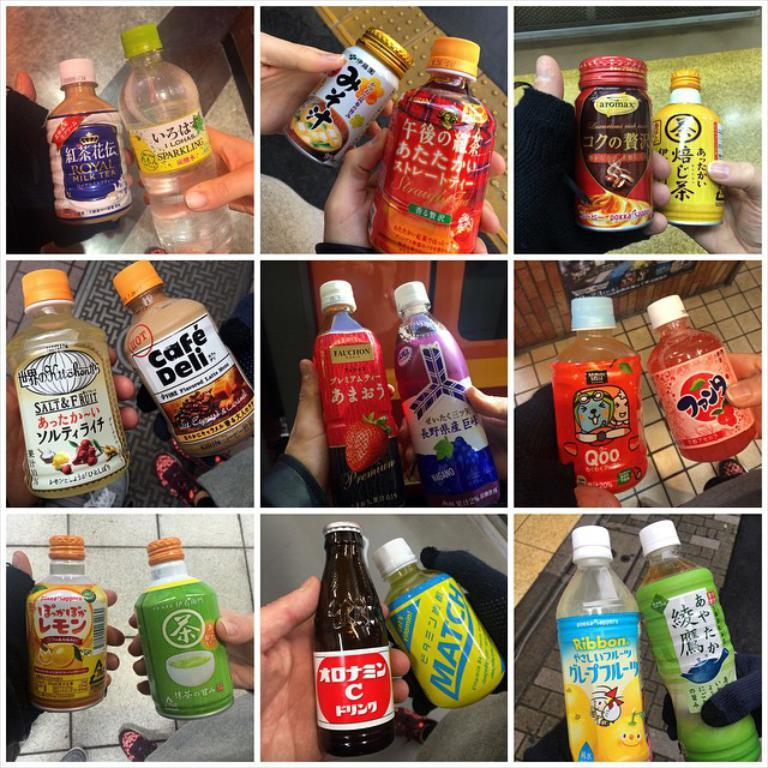<image>
Relay a brief, clear account of the picture shown. the letter C is on the front of the bottle 